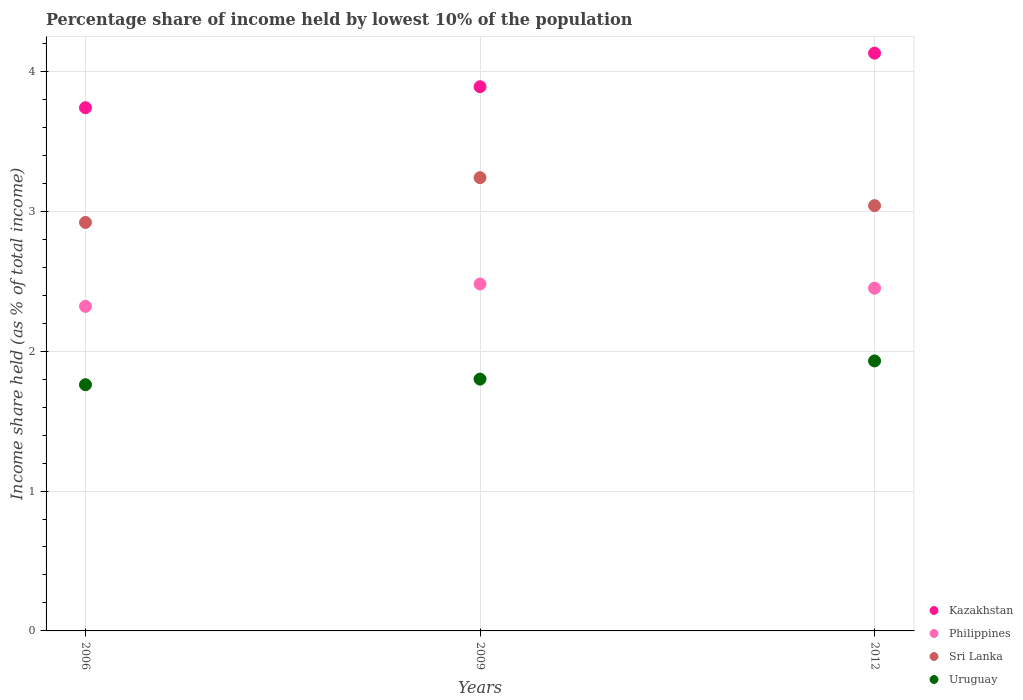How many different coloured dotlines are there?
Your response must be concise. 4. What is the percentage share of income held by lowest 10% of the population in Kazakhstan in 2006?
Keep it short and to the point. 3.74. Across all years, what is the maximum percentage share of income held by lowest 10% of the population in Uruguay?
Your answer should be compact. 1.93. Across all years, what is the minimum percentage share of income held by lowest 10% of the population in Sri Lanka?
Provide a succinct answer. 2.92. In which year was the percentage share of income held by lowest 10% of the population in Sri Lanka maximum?
Offer a terse response. 2009. In which year was the percentage share of income held by lowest 10% of the population in Sri Lanka minimum?
Provide a succinct answer. 2006. What is the total percentage share of income held by lowest 10% of the population in Sri Lanka in the graph?
Make the answer very short. 9.2. What is the difference between the percentage share of income held by lowest 10% of the population in Sri Lanka in 2009 and that in 2012?
Make the answer very short. 0.2. What is the difference between the percentage share of income held by lowest 10% of the population in Sri Lanka in 2006 and the percentage share of income held by lowest 10% of the population in Kazakhstan in 2009?
Give a very brief answer. -0.97. What is the average percentage share of income held by lowest 10% of the population in Sri Lanka per year?
Your response must be concise. 3.07. In the year 2006, what is the difference between the percentage share of income held by lowest 10% of the population in Kazakhstan and percentage share of income held by lowest 10% of the population in Philippines?
Give a very brief answer. 1.42. What is the ratio of the percentage share of income held by lowest 10% of the population in Sri Lanka in 2006 to that in 2009?
Your response must be concise. 0.9. Is the difference between the percentage share of income held by lowest 10% of the population in Kazakhstan in 2009 and 2012 greater than the difference between the percentage share of income held by lowest 10% of the population in Philippines in 2009 and 2012?
Ensure brevity in your answer.  No. What is the difference between the highest and the second highest percentage share of income held by lowest 10% of the population in Philippines?
Offer a very short reply. 0.03. What is the difference between the highest and the lowest percentage share of income held by lowest 10% of the population in Kazakhstan?
Your answer should be compact. 0.39. Is the sum of the percentage share of income held by lowest 10% of the population in Kazakhstan in 2009 and 2012 greater than the maximum percentage share of income held by lowest 10% of the population in Sri Lanka across all years?
Keep it short and to the point. Yes. Is it the case that in every year, the sum of the percentage share of income held by lowest 10% of the population in Kazakhstan and percentage share of income held by lowest 10% of the population in Philippines  is greater than the percentage share of income held by lowest 10% of the population in Sri Lanka?
Provide a succinct answer. Yes. Is the percentage share of income held by lowest 10% of the population in Uruguay strictly greater than the percentage share of income held by lowest 10% of the population in Kazakhstan over the years?
Your answer should be compact. No. Is the percentage share of income held by lowest 10% of the population in Uruguay strictly less than the percentage share of income held by lowest 10% of the population in Sri Lanka over the years?
Offer a terse response. Yes. How many dotlines are there?
Your answer should be compact. 4. How many years are there in the graph?
Offer a very short reply. 3. What is the difference between two consecutive major ticks on the Y-axis?
Offer a terse response. 1. Are the values on the major ticks of Y-axis written in scientific E-notation?
Give a very brief answer. No. Does the graph contain any zero values?
Offer a very short reply. No. Does the graph contain grids?
Your answer should be very brief. Yes. Where does the legend appear in the graph?
Keep it short and to the point. Bottom right. How many legend labels are there?
Provide a short and direct response. 4. How are the legend labels stacked?
Offer a terse response. Vertical. What is the title of the graph?
Your response must be concise. Percentage share of income held by lowest 10% of the population. What is the label or title of the X-axis?
Your response must be concise. Years. What is the label or title of the Y-axis?
Provide a short and direct response. Income share held (as % of total income). What is the Income share held (as % of total income) in Kazakhstan in 2006?
Ensure brevity in your answer.  3.74. What is the Income share held (as % of total income) of Philippines in 2006?
Give a very brief answer. 2.32. What is the Income share held (as % of total income) in Sri Lanka in 2006?
Offer a very short reply. 2.92. What is the Income share held (as % of total income) in Uruguay in 2006?
Your answer should be compact. 1.76. What is the Income share held (as % of total income) in Kazakhstan in 2009?
Your answer should be very brief. 3.89. What is the Income share held (as % of total income) of Philippines in 2009?
Ensure brevity in your answer.  2.48. What is the Income share held (as % of total income) in Sri Lanka in 2009?
Give a very brief answer. 3.24. What is the Income share held (as % of total income) of Uruguay in 2009?
Offer a very short reply. 1.8. What is the Income share held (as % of total income) of Kazakhstan in 2012?
Provide a succinct answer. 4.13. What is the Income share held (as % of total income) in Philippines in 2012?
Keep it short and to the point. 2.45. What is the Income share held (as % of total income) of Sri Lanka in 2012?
Make the answer very short. 3.04. What is the Income share held (as % of total income) in Uruguay in 2012?
Offer a terse response. 1.93. Across all years, what is the maximum Income share held (as % of total income) in Kazakhstan?
Offer a very short reply. 4.13. Across all years, what is the maximum Income share held (as % of total income) of Philippines?
Make the answer very short. 2.48. Across all years, what is the maximum Income share held (as % of total income) of Sri Lanka?
Make the answer very short. 3.24. Across all years, what is the maximum Income share held (as % of total income) of Uruguay?
Your answer should be very brief. 1.93. Across all years, what is the minimum Income share held (as % of total income) in Kazakhstan?
Your answer should be compact. 3.74. Across all years, what is the minimum Income share held (as % of total income) of Philippines?
Give a very brief answer. 2.32. Across all years, what is the minimum Income share held (as % of total income) of Sri Lanka?
Keep it short and to the point. 2.92. Across all years, what is the minimum Income share held (as % of total income) in Uruguay?
Offer a terse response. 1.76. What is the total Income share held (as % of total income) in Kazakhstan in the graph?
Make the answer very short. 11.76. What is the total Income share held (as % of total income) in Philippines in the graph?
Ensure brevity in your answer.  7.25. What is the total Income share held (as % of total income) of Uruguay in the graph?
Provide a succinct answer. 5.49. What is the difference between the Income share held (as % of total income) of Kazakhstan in 2006 and that in 2009?
Keep it short and to the point. -0.15. What is the difference between the Income share held (as % of total income) of Philippines in 2006 and that in 2009?
Ensure brevity in your answer.  -0.16. What is the difference between the Income share held (as % of total income) in Sri Lanka in 2006 and that in 2009?
Offer a very short reply. -0.32. What is the difference between the Income share held (as % of total income) of Uruguay in 2006 and that in 2009?
Keep it short and to the point. -0.04. What is the difference between the Income share held (as % of total income) in Kazakhstan in 2006 and that in 2012?
Provide a succinct answer. -0.39. What is the difference between the Income share held (as % of total income) of Philippines in 2006 and that in 2012?
Give a very brief answer. -0.13. What is the difference between the Income share held (as % of total income) of Sri Lanka in 2006 and that in 2012?
Your answer should be compact. -0.12. What is the difference between the Income share held (as % of total income) of Uruguay in 2006 and that in 2012?
Your response must be concise. -0.17. What is the difference between the Income share held (as % of total income) of Kazakhstan in 2009 and that in 2012?
Provide a succinct answer. -0.24. What is the difference between the Income share held (as % of total income) in Uruguay in 2009 and that in 2012?
Offer a terse response. -0.13. What is the difference between the Income share held (as % of total income) of Kazakhstan in 2006 and the Income share held (as % of total income) of Philippines in 2009?
Your response must be concise. 1.26. What is the difference between the Income share held (as % of total income) in Kazakhstan in 2006 and the Income share held (as % of total income) in Sri Lanka in 2009?
Provide a short and direct response. 0.5. What is the difference between the Income share held (as % of total income) in Kazakhstan in 2006 and the Income share held (as % of total income) in Uruguay in 2009?
Your answer should be compact. 1.94. What is the difference between the Income share held (as % of total income) in Philippines in 2006 and the Income share held (as % of total income) in Sri Lanka in 2009?
Give a very brief answer. -0.92. What is the difference between the Income share held (as % of total income) of Philippines in 2006 and the Income share held (as % of total income) of Uruguay in 2009?
Offer a terse response. 0.52. What is the difference between the Income share held (as % of total income) of Sri Lanka in 2006 and the Income share held (as % of total income) of Uruguay in 2009?
Make the answer very short. 1.12. What is the difference between the Income share held (as % of total income) in Kazakhstan in 2006 and the Income share held (as % of total income) in Philippines in 2012?
Offer a very short reply. 1.29. What is the difference between the Income share held (as % of total income) in Kazakhstan in 2006 and the Income share held (as % of total income) in Uruguay in 2012?
Offer a terse response. 1.81. What is the difference between the Income share held (as % of total income) of Philippines in 2006 and the Income share held (as % of total income) of Sri Lanka in 2012?
Ensure brevity in your answer.  -0.72. What is the difference between the Income share held (as % of total income) of Philippines in 2006 and the Income share held (as % of total income) of Uruguay in 2012?
Keep it short and to the point. 0.39. What is the difference between the Income share held (as % of total income) of Sri Lanka in 2006 and the Income share held (as % of total income) of Uruguay in 2012?
Provide a short and direct response. 0.99. What is the difference between the Income share held (as % of total income) of Kazakhstan in 2009 and the Income share held (as % of total income) of Philippines in 2012?
Give a very brief answer. 1.44. What is the difference between the Income share held (as % of total income) of Kazakhstan in 2009 and the Income share held (as % of total income) of Uruguay in 2012?
Your answer should be very brief. 1.96. What is the difference between the Income share held (as % of total income) of Philippines in 2009 and the Income share held (as % of total income) of Sri Lanka in 2012?
Your answer should be very brief. -0.56. What is the difference between the Income share held (as % of total income) of Philippines in 2009 and the Income share held (as % of total income) of Uruguay in 2012?
Give a very brief answer. 0.55. What is the difference between the Income share held (as % of total income) of Sri Lanka in 2009 and the Income share held (as % of total income) of Uruguay in 2012?
Provide a succinct answer. 1.31. What is the average Income share held (as % of total income) of Kazakhstan per year?
Give a very brief answer. 3.92. What is the average Income share held (as % of total income) in Philippines per year?
Give a very brief answer. 2.42. What is the average Income share held (as % of total income) of Sri Lanka per year?
Offer a terse response. 3.07. What is the average Income share held (as % of total income) of Uruguay per year?
Your answer should be very brief. 1.83. In the year 2006, what is the difference between the Income share held (as % of total income) of Kazakhstan and Income share held (as % of total income) of Philippines?
Provide a succinct answer. 1.42. In the year 2006, what is the difference between the Income share held (as % of total income) in Kazakhstan and Income share held (as % of total income) in Sri Lanka?
Your answer should be compact. 0.82. In the year 2006, what is the difference between the Income share held (as % of total income) in Kazakhstan and Income share held (as % of total income) in Uruguay?
Your response must be concise. 1.98. In the year 2006, what is the difference between the Income share held (as % of total income) in Philippines and Income share held (as % of total income) in Sri Lanka?
Your answer should be very brief. -0.6. In the year 2006, what is the difference between the Income share held (as % of total income) in Philippines and Income share held (as % of total income) in Uruguay?
Keep it short and to the point. 0.56. In the year 2006, what is the difference between the Income share held (as % of total income) of Sri Lanka and Income share held (as % of total income) of Uruguay?
Provide a short and direct response. 1.16. In the year 2009, what is the difference between the Income share held (as % of total income) of Kazakhstan and Income share held (as % of total income) of Philippines?
Provide a succinct answer. 1.41. In the year 2009, what is the difference between the Income share held (as % of total income) in Kazakhstan and Income share held (as % of total income) in Sri Lanka?
Provide a succinct answer. 0.65. In the year 2009, what is the difference between the Income share held (as % of total income) in Kazakhstan and Income share held (as % of total income) in Uruguay?
Offer a very short reply. 2.09. In the year 2009, what is the difference between the Income share held (as % of total income) of Philippines and Income share held (as % of total income) of Sri Lanka?
Offer a terse response. -0.76. In the year 2009, what is the difference between the Income share held (as % of total income) of Philippines and Income share held (as % of total income) of Uruguay?
Your answer should be compact. 0.68. In the year 2009, what is the difference between the Income share held (as % of total income) of Sri Lanka and Income share held (as % of total income) of Uruguay?
Your answer should be compact. 1.44. In the year 2012, what is the difference between the Income share held (as % of total income) of Kazakhstan and Income share held (as % of total income) of Philippines?
Give a very brief answer. 1.68. In the year 2012, what is the difference between the Income share held (as % of total income) in Kazakhstan and Income share held (as % of total income) in Sri Lanka?
Offer a very short reply. 1.09. In the year 2012, what is the difference between the Income share held (as % of total income) of Philippines and Income share held (as % of total income) of Sri Lanka?
Your answer should be compact. -0.59. In the year 2012, what is the difference between the Income share held (as % of total income) in Philippines and Income share held (as % of total income) in Uruguay?
Ensure brevity in your answer.  0.52. In the year 2012, what is the difference between the Income share held (as % of total income) in Sri Lanka and Income share held (as % of total income) in Uruguay?
Your answer should be compact. 1.11. What is the ratio of the Income share held (as % of total income) in Kazakhstan in 2006 to that in 2009?
Provide a short and direct response. 0.96. What is the ratio of the Income share held (as % of total income) in Philippines in 2006 to that in 2009?
Your answer should be very brief. 0.94. What is the ratio of the Income share held (as % of total income) in Sri Lanka in 2006 to that in 2009?
Keep it short and to the point. 0.9. What is the ratio of the Income share held (as % of total income) in Uruguay in 2006 to that in 2009?
Provide a short and direct response. 0.98. What is the ratio of the Income share held (as % of total income) of Kazakhstan in 2006 to that in 2012?
Your answer should be very brief. 0.91. What is the ratio of the Income share held (as % of total income) in Philippines in 2006 to that in 2012?
Your answer should be very brief. 0.95. What is the ratio of the Income share held (as % of total income) in Sri Lanka in 2006 to that in 2012?
Provide a succinct answer. 0.96. What is the ratio of the Income share held (as % of total income) in Uruguay in 2006 to that in 2012?
Keep it short and to the point. 0.91. What is the ratio of the Income share held (as % of total income) of Kazakhstan in 2009 to that in 2012?
Provide a short and direct response. 0.94. What is the ratio of the Income share held (as % of total income) of Philippines in 2009 to that in 2012?
Provide a succinct answer. 1.01. What is the ratio of the Income share held (as % of total income) in Sri Lanka in 2009 to that in 2012?
Your answer should be very brief. 1.07. What is the ratio of the Income share held (as % of total income) of Uruguay in 2009 to that in 2012?
Provide a succinct answer. 0.93. What is the difference between the highest and the second highest Income share held (as % of total income) of Kazakhstan?
Offer a terse response. 0.24. What is the difference between the highest and the second highest Income share held (as % of total income) in Philippines?
Provide a succinct answer. 0.03. What is the difference between the highest and the second highest Income share held (as % of total income) in Uruguay?
Provide a succinct answer. 0.13. What is the difference between the highest and the lowest Income share held (as % of total income) of Kazakhstan?
Give a very brief answer. 0.39. What is the difference between the highest and the lowest Income share held (as % of total income) in Philippines?
Provide a succinct answer. 0.16. What is the difference between the highest and the lowest Income share held (as % of total income) of Sri Lanka?
Give a very brief answer. 0.32. What is the difference between the highest and the lowest Income share held (as % of total income) of Uruguay?
Offer a very short reply. 0.17. 